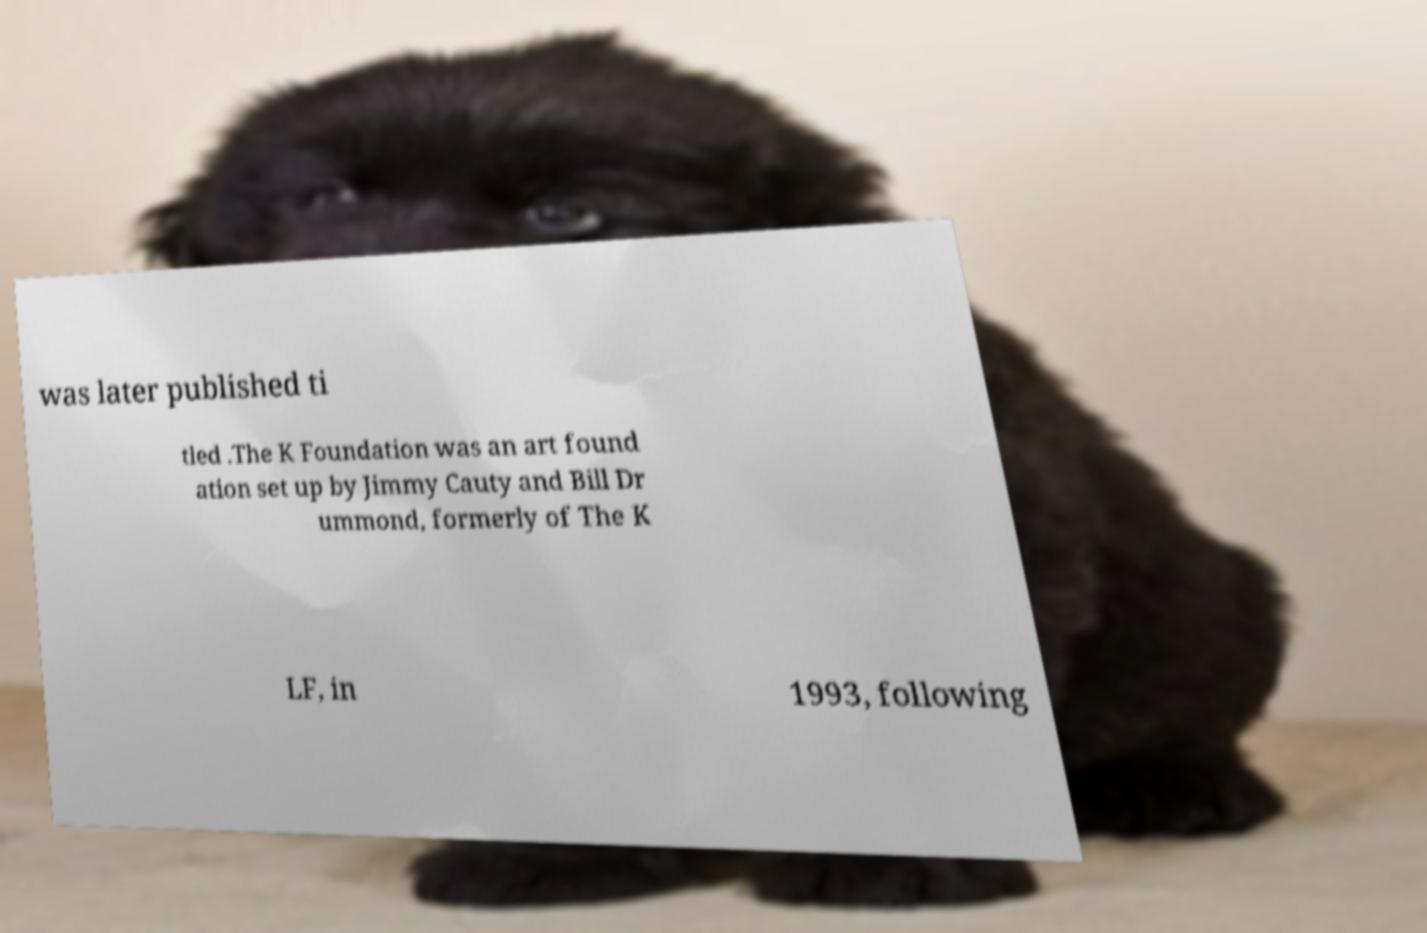For documentation purposes, I need the text within this image transcribed. Could you provide that? was later published ti tled .The K Foundation was an art found ation set up by Jimmy Cauty and Bill Dr ummond, formerly of The K LF, in 1993, following 